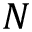<formula> <loc_0><loc_0><loc_500><loc_500>N</formula> 